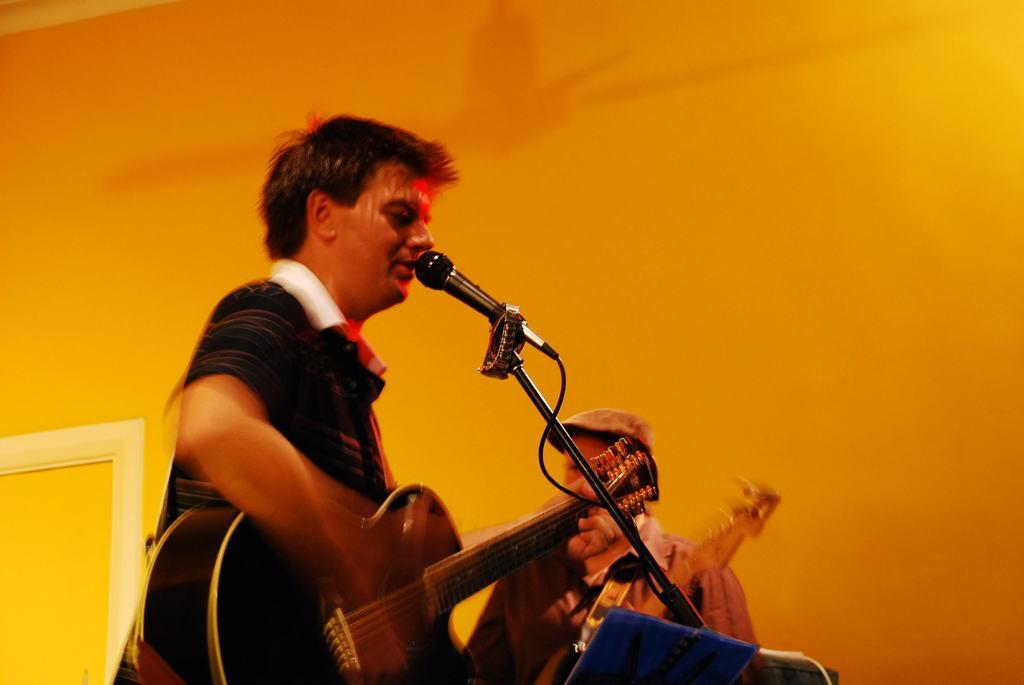In one or two sentences, can you explain what this image depicts? In this Image I see 2 persons, in which this man is holding a guitar and is standing in front of the mic. In the background I see the wall which is orange in color. 